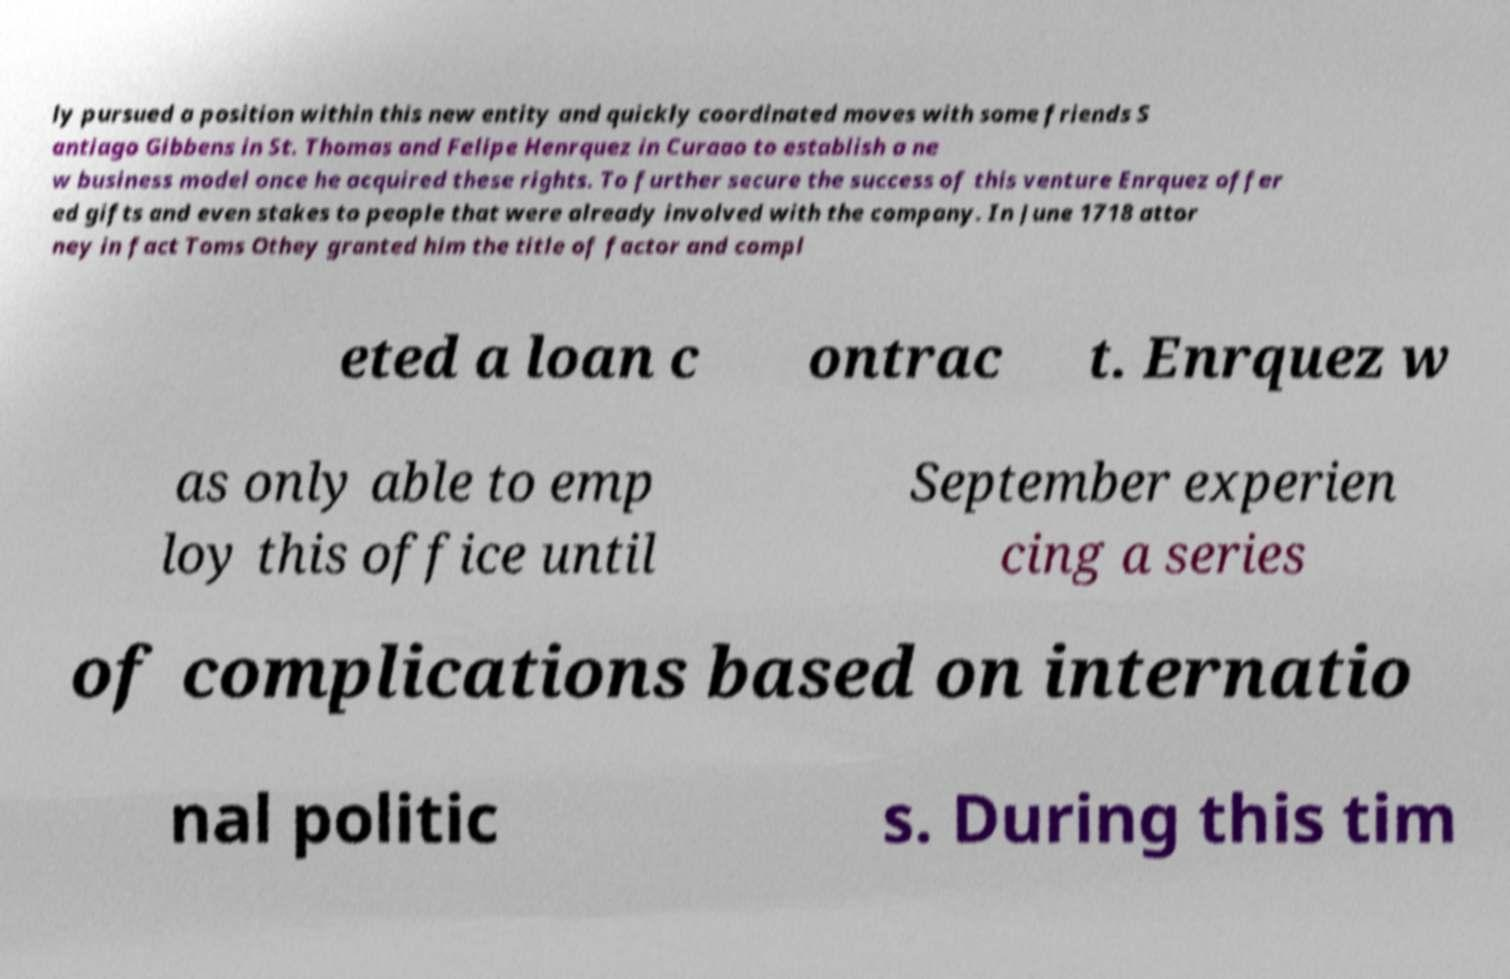Could you assist in decoding the text presented in this image and type it out clearly? ly pursued a position within this new entity and quickly coordinated moves with some friends S antiago Gibbens in St. Thomas and Felipe Henrquez in Curaao to establish a ne w business model once he acquired these rights. To further secure the success of this venture Enrquez offer ed gifts and even stakes to people that were already involved with the company. In June 1718 attor ney in fact Toms Othey granted him the title of factor and compl eted a loan c ontrac t. Enrquez w as only able to emp loy this office until September experien cing a series of complications based on internatio nal politic s. During this tim 